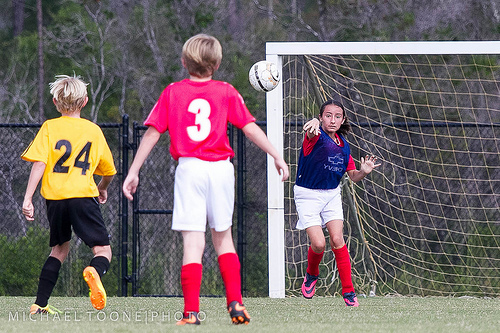<image>
Is the soccer to the right of the shoes? Yes. From this viewpoint, the soccer is positioned to the right side relative to the shoes. Is there a boy to the right of the boy? Yes. From this viewpoint, the boy is positioned to the right side relative to the boy. Where is the ball in relation to the child? Is it in front of the child? No. The ball is not in front of the child. The spatial positioning shows a different relationship between these objects. Where is the ball in relation to the fence? Is it above the fence? No. The ball is not positioned above the fence. The vertical arrangement shows a different relationship. 